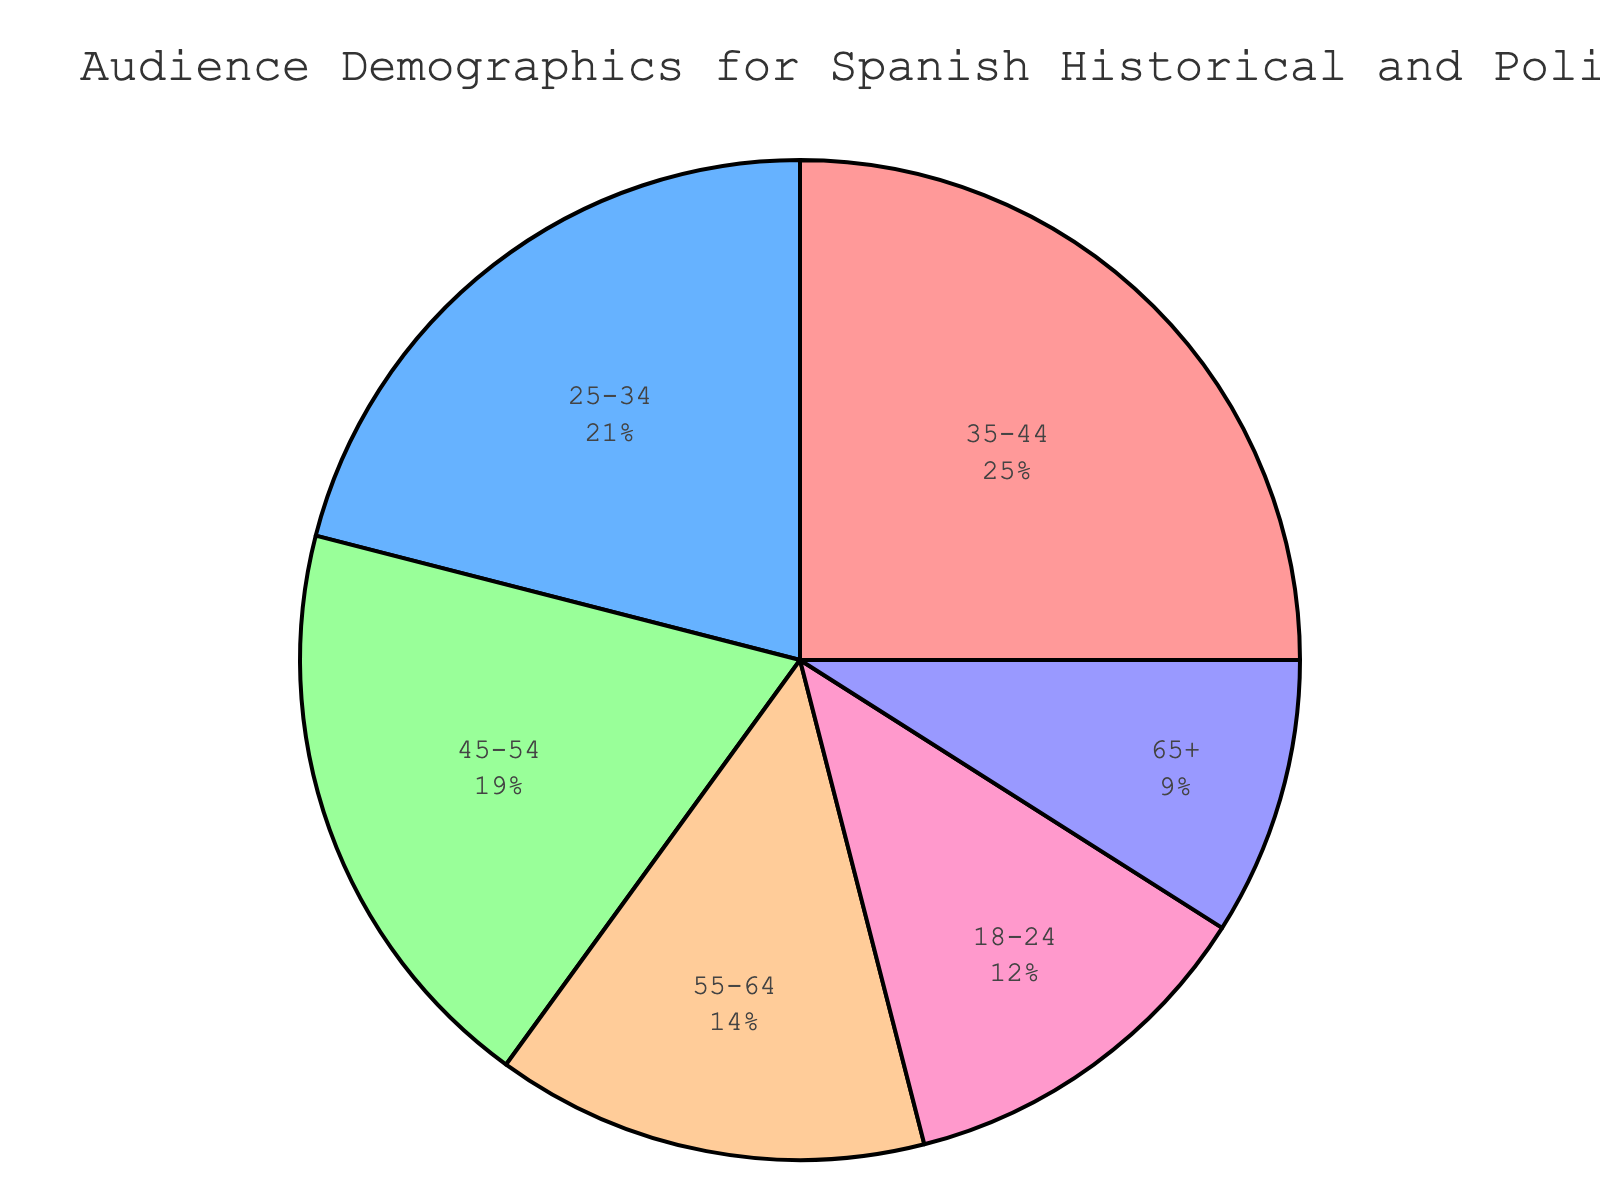What's the largest age group among the audience for Spanish historical and political movies? Look at the segment with the highest percentage in the pie chart. The 35-44 age group holds the largest portion at 25%.
Answer: 35-44 Which age group has the smallest representation in the audience? Identify the segment with the smallest percentage in the pie chart. The 65+ age group has the smallest portion at 9%.
Answer: 65+ How much higher is the percentage of the 35-44 age group compared to the 65+ age group? Subtract the percentage of the 65+ age group from the percentage of the 35-44 age group: 25% - 9% = 16%.
Answer: 16% Combine the percentages of the youngest and the oldest age groups. What total do you get? Add the percentages of the 18-24 age group and the 65+ age group: 12% + 9% = 21%.
Answer: 21% Which age group has a percentage closest to the combined percentage of the 45-54 and 55-64 age groups? First, add the percentages of the 45-54 and 55-64 age groups: 19% + 14% = 33%. Then compare with other group percentages. No exact match, but the 25-34 age group is the next closest at 21%.
Answer: 25-34 Is the percentage of the 25-34 age group greater than the sum of the 55-64 and 65+ age groups? First, sum the percentages of 55-64 and 65+ age groups: 14% + 9% = 23%. Then compare with the 25-34 percentage: 21% < 23%.
Answer: No What percentage of the audience is 45 or older? Sum the percentages of the 45-54, 55-64, and 65+ age groups: 19% + 14% + 9% = 42%.
Answer: 42% Of the age groups represented by red and blue segments, which has a larger audience percentage? Identify the colors used in the pie chart. The red segment (18-24) is 12% and the blue segment (25-34) is 21%. 21% is larger than 12%.
Answer: 25-34 What is the average percentage of all the age groups? Sum all the percentages: 12% + 21% + 25% + 19% + 14% + 9% = 100%. Then divide by the number of groups: 100% / 6 = 16.67%.
Answer: 16.67% Which age groups comprise more than half of the total audience? Identify groups whose sums exceed 50%. The 35-44 (25%), 25-34 (21%), and 45-54 (19%) combined sum to over 50% (65%).
Answer: 35-44, 25-34, and 45-54 